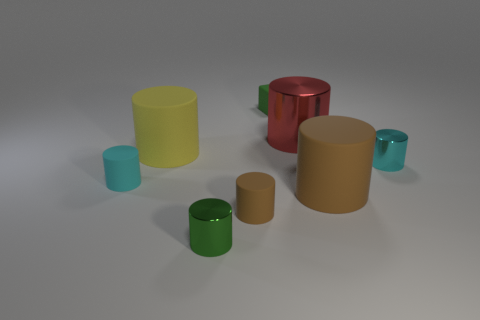How big is the rubber object behind the big yellow cylinder?
Your answer should be compact. Small. What shape is the large yellow object that is the same material as the small green block?
Offer a very short reply. Cylinder. Do the green cube and the green object that is in front of the block have the same material?
Provide a short and direct response. No. Does the small green thing in front of the green matte cube have the same shape as the tiny brown rubber object?
Your answer should be very brief. Yes. There is a yellow object that is the same shape as the small brown matte object; what is it made of?
Make the answer very short. Rubber. There is a yellow matte thing; is its shape the same as the small metallic thing on the left side of the red shiny thing?
Offer a terse response. Yes. What color is the cylinder that is both left of the tiny brown rubber thing and in front of the cyan rubber cylinder?
Make the answer very short. Green. Is there a yellow matte cylinder?
Make the answer very short. Yes. Is the number of small green metallic objects behind the big brown cylinder the same as the number of small cylinders?
Offer a terse response. No. How many other objects are there of the same shape as the large red thing?
Your response must be concise. 6. 